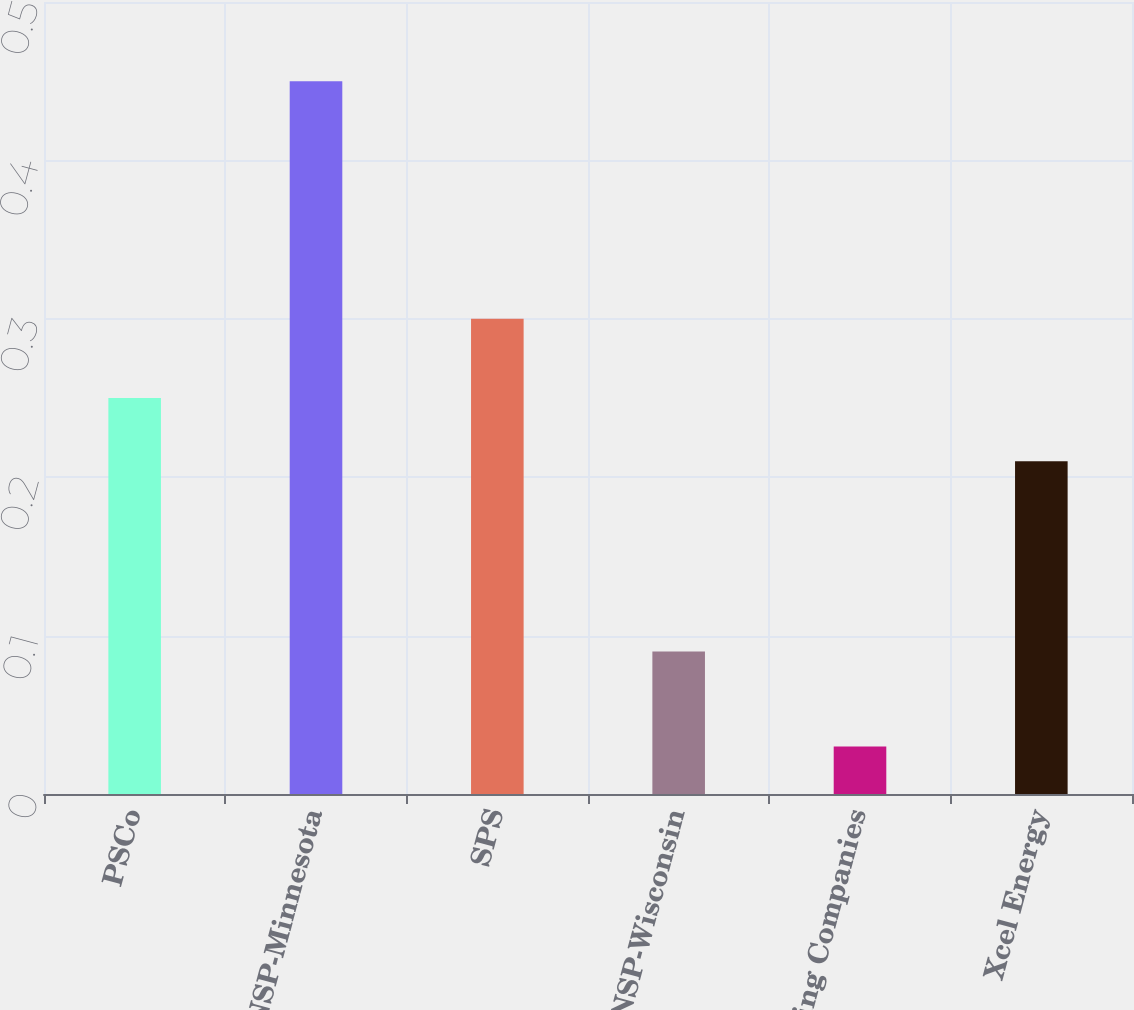Convert chart. <chart><loc_0><loc_0><loc_500><loc_500><bar_chart><fcel>PSCo<fcel>NSP-Minnesota<fcel>SPS<fcel>NSP-Wisconsin<fcel>Operating Companies<fcel>Xcel Energy<nl><fcel>0.25<fcel>0.45<fcel>0.3<fcel>0.09<fcel>0.03<fcel>0.21<nl></chart> 